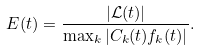<formula> <loc_0><loc_0><loc_500><loc_500>E ( t ) = \frac { | \mathcal { L } ( t ) | } { \max _ { k } | C _ { k } ( t ) f _ { k } ( t ) | } .</formula> 